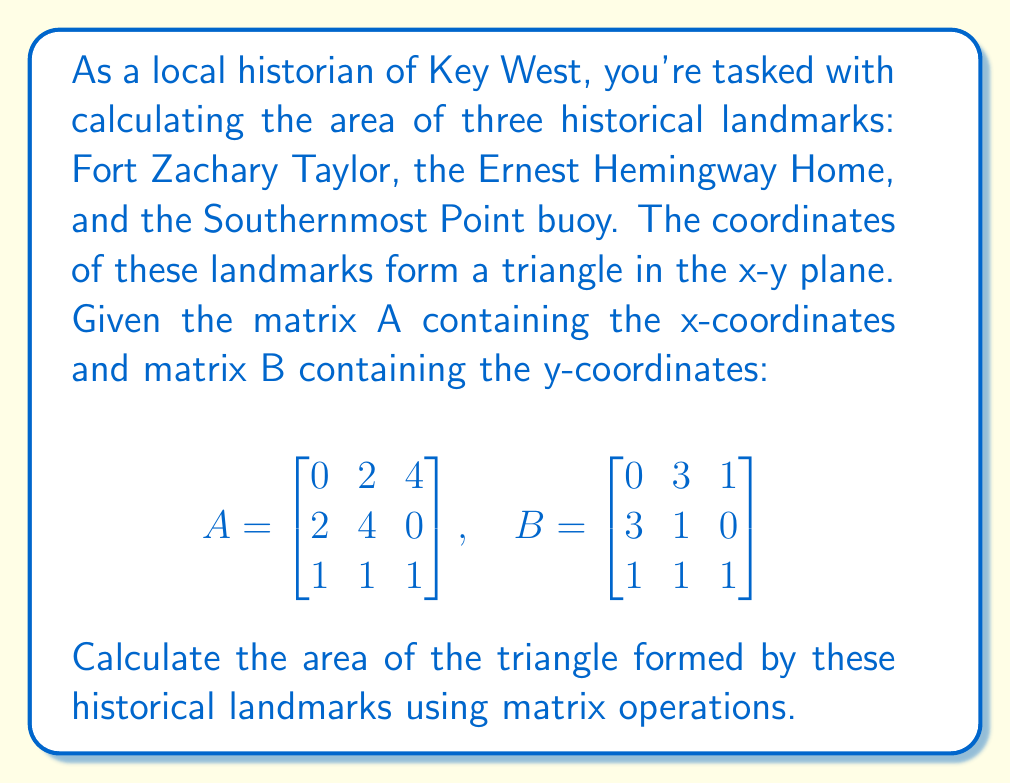Show me your answer to this math problem. To solve this problem, we'll use the following steps:

1) The formula for the area of a triangle using matrices is:

   $$\text{Area} = \frac{1}{2}|\det(C)|$$

   where C is the matrix formed by subtracting one vertex from the other two.

2) Let's choose the first point (0,0) as our reference point. We'll subtract it from the other two points:

   $$C = \begin{bmatrix} 
   2-0 & 4-0 \\
   3-0 & 1-0
   \end{bmatrix} = \begin{bmatrix}
   2 & 4 \\
   3 & 1
   \end{bmatrix}$$

3) Now we need to calculate the determinant of C:

   $$\det(C) = (2)(1) - (4)(3) = 2 - 12 = -10$$

4) The area is half the absolute value of this determinant:

   $$\text{Area} = \frac{1}{2}|-10| = 5$$

Therefore, the area of the triangle formed by these historical Key West landmarks is 5 square units.
Answer: 5 square units 